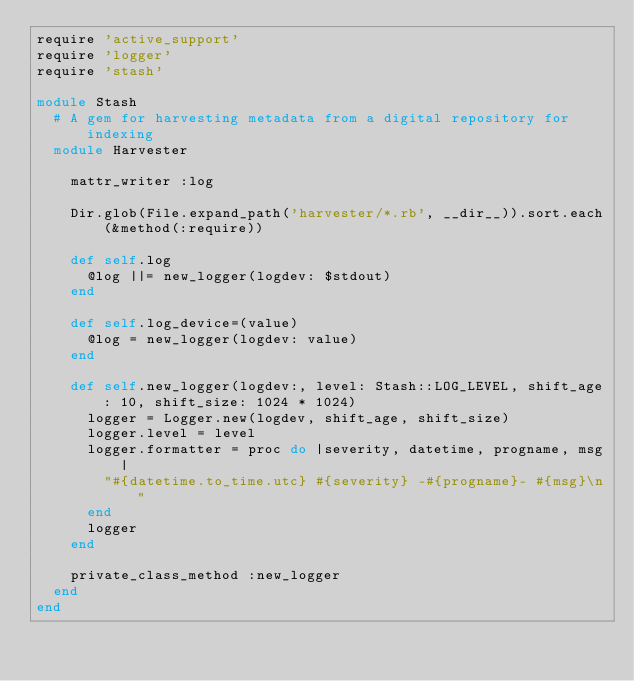Convert code to text. <code><loc_0><loc_0><loc_500><loc_500><_Ruby_>require 'active_support'
require 'logger'
require 'stash'

module Stash
  # A gem for harvesting metadata from a digital repository for indexing
  module Harvester

    mattr_writer :log

    Dir.glob(File.expand_path('harvester/*.rb', __dir__)).sort.each(&method(:require))

    def self.log
      @log ||= new_logger(logdev: $stdout)
    end

    def self.log_device=(value)
      @log = new_logger(logdev: value)
    end

    def self.new_logger(logdev:, level: Stash::LOG_LEVEL, shift_age: 10, shift_size: 1024 * 1024)
      logger = Logger.new(logdev, shift_age, shift_size)
      logger.level = level
      logger.formatter = proc do |severity, datetime, progname, msg|
        "#{datetime.to_time.utc} #{severity} -#{progname}- #{msg}\n"
      end
      logger
    end

    private_class_method :new_logger
  end
end
</code> 